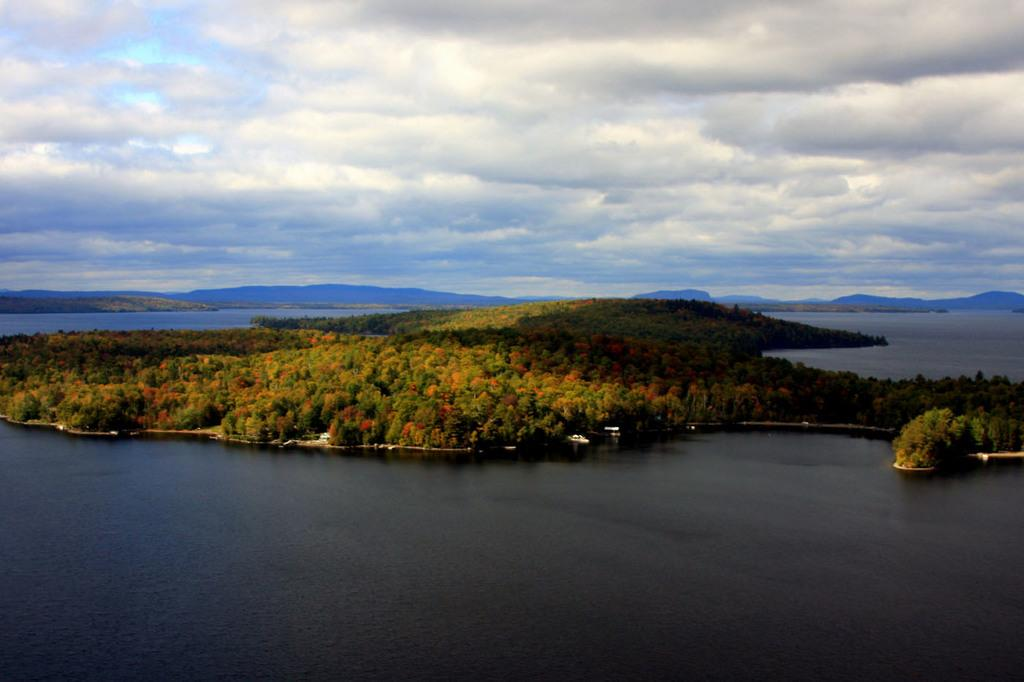What is the main element present in the image? There is water in the image. What type of natural vegetation can be seen in the image? There are trees in the image. What type of landscape feature is present in the image? There are hills in the image. What is the condition of the sky in the image? The sky is cloudy in the image. What type of wine is being served in the image? There is no wine present in the image; it features water, trees, hills, and a cloudy sky. Is there a can visible in the image? There is no can present in the image. 